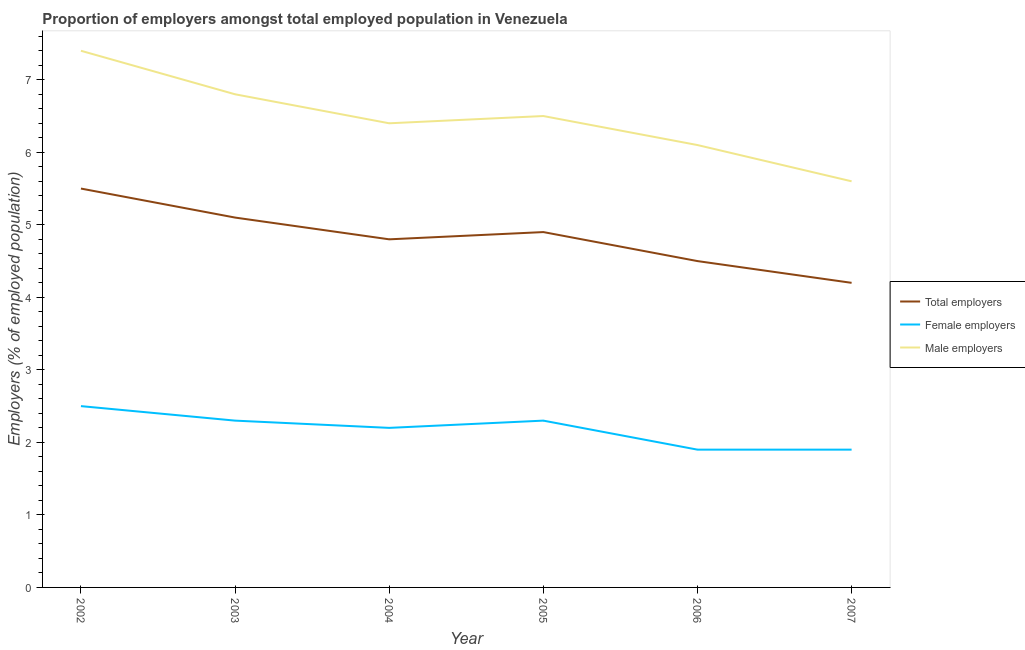Is the number of lines equal to the number of legend labels?
Your response must be concise. Yes. What is the percentage of male employers in 2003?
Your answer should be very brief. 6.8. Across all years, what is the minimum percentage of female employers?
Make the answer very short. 1.9. What is the total percentage of male employers in the graph?
Provide a succinct answer. 38.8. What is the difference between the percentage of male employers in 2002 and that in 2003?
Keep it short and to the point. 0.6. What is the difference between the percentage of male employers in 2005 and the percentage of total employers in 2003?
Offer a very short reply. 1.4. What is the average percentage of female employers per year?
Give a very brief answer. 2.18. In the year 2006, what is the difference between the percentage of female employers and percentage of total employers?
Keep it short and to the point. -2.6. In how many years, is the percentage of female employers greater than 6.4 %?
Your answer should be very brief. 0. What is the ratio of the percentage of male employers in 2003 to that in 2007?
Your answer should be compact. 1.21. Is the difference between the percentage of total employers in 2002 and 2005 greater than the difference between the percentage of male employers in 2002 and 2005?
Give a very brief answer. No. What is the difference between the highest and the second highest percentage of total employers?
Provide a succinct answer. 0.4. What is the difference between the highest and the lowest percentage of female employers?
Provide a succinct answer. 0.6. Is it the case that in every year, the sum of the percentage of total employers and percentage of female employers is greater than the percentage of male employers?
Your answer should be very brief. Yes. Is the percentage of female employers strictly greater than the percentage of male employers over the years?
Provide a short and direct response. No. Is the percentage of male employers strictly less than the percentage of total employers over the years?
Provide a succinct answer. No. How many lines are there?
Ensure brevity in your answer.  3. How many years are there in the graph?
Your response must be concise. 6. Are the values on the major ticks of Y-axis written in scientific E-notation?
Offer a terse response. No. Where does the legend appear in the graph?
Keep it short and to the point. Center right. How many legend labels are there?
Your response must be concise. 3. How are the legend labels stacked?
Ensure brevity in your answer.  Vertical. What is the title of the graph?
Ensure brevity in your answer.  Proportion of employers amongst total employed population in Venezuela. What is the label or title of the X-axis?
Provide a succinct answer. Year. What is the label or title of the Y-axis?
Ensure brevity in your answer.  Employers (% of employed population). What is the Employers (% of employed population) in Male employers in 2002?
Provide a short and direct response. 7.4. What is the Employers (% of employed population) in Total employers in 2003?
Your answer should be compact. 5.1. What is the Employers (% of employed population) in Female employers in 2003?
Your answer should be very brief. 2.3. What is the Employers (% of employed population) of Male employers in 2003?
Your answer should be compact. 6.8. What is the Employers (% of employed population) of Total employers in 2004?
Provide a succinct answer. 4.8. What is the Employers (% of employed population) of Female employers in 2004?
Give a very brief answer. 2.2. What is the Employers (% of employed population) of Male employers in 2004?
Give a very brief answer. 6.4. What is the Employers (% of employed population) in Total employers in 2005?
Offer a terse response. 4.9. What is the Employers (% of employed population) of Female employers in 2005?
Make the answer very short. 2.3. What is the Employers (% of employed population) of Total employers in 2006?
Offer a terse response. 4.5. What is the Employers (% of employed population) of Female employers in 2006?
Provide a succinct answer. 1.9. What is the Employers (% of employed population) of Male employers in 2006?
Offer a very short reply. 6.1. What is the Employers (% of employed population) in Total employers in 2007?
Offer a terse response. 4.2. What is the Employers (% of employed population) of Female employers in 2007?
Provide a short and direct response. 1.9. What is the Employers (% of employed population) of Male employers in 2007?
Give a very brief answer. 5.6. Across all years, what is the maximum Employers (% of employed population) in Female employers?
Your answer should be very brief. 2.5. Across all years, what is the maximum Employers (% of employed population) in Male employers?
Give a very brief answer. 7.4. Across all years, what is the minimum Employers (% of employed population) of Total employers?
Keep it short and to the point. 4.2. Across all years, what is the minimum Employers (% of employed population) of Female employers?
Your answer should be very brief. 1.9. Across all years, what is the minimum Employers (% of employed population) of Male employers?
Make the answer very short. 5.6. What is the total Employers (% of employed population) of Total employers in the graph?
Keep it short and to the point. 29. What is the total Employers (% of employed population) in Female employers in the graph?
Offer a very short reply. 13.1. What is the total Employers (% of employed population) of Male employers in the graph?
Make the answer very short. 38.8. What is the difference between the Employers (% of employed population) in Total employers in 2002 and that in 2003?
Your answer should be compact. 0.4. What is the difference between the Employers (% of employed population) of Female employers in 2002 and that in 2003?
Keep it short and to the point. 0.2. What is the difference between the Employers (% of employed population) of Male employers in 2002 and that in 2004?
Offer a very short reply. 1. What is the difference between the Employers (% of employed population) of Male employers in 2002 and that in 2005?
Offer a terse response. 0.9. What is the difference between the Employers (% of employed population) in Total employers in 2002 and that in 2007?
Give a very brief answer. 1.3. What is the difference between the Employers (% of employed population) in Female employers in 2002 and that in 2007?
Your answer should be compact. 0.6. What is the difference between the Employers (% of employed population) of Total employers in 2003 and that in 2004?
Your answer should be very brief. 0.3. What is the difference between the Employers (% of employed population) of Male employers in 2003 and that in 2005?
Keep it short and to the point. 0.3. What is the difference between the Employers (% of employed population) in Male employers in 2003 and that in 2006?
Your answer should be very brief. 0.7. What is the difference between the Employers (% of employed population) in Female employers in 2004 and that in 2005?
Ensure brevity in your answer.  -0.1. What is the difference between the Employers (% of employed population) of Male employers in 2004 and that in 2005?
Give a very brief answer. -0.1. What is the difference between the Employers (% of employed population) of Total employers in 2004 and that in 2006?
Keep it short and to the point. 0.3. What is the difference between the Employers (% of employed population) in Female employers in 2004 and that in 2006?
Offer a terse response. 0.3. What is the difference between the Employers (% of employed population) of Total employers in 2004 and that in 2007?
Make the answer very short. 0.6. What is the difference between the Employers (% of employed population) in Female employers in 2005 and that in 2006?
Your response must be concise. 0.4. What is the difference between the Employers (% of employed population) of Male employers in 2005 and that in 2007?
Provide a short and direct response. 0.9. What is the difference between the Employers (% of employed population) of Total employers in 2006 and that in 2007?
Make the answer very short. 0.3. What is the difference between the Employers (% of employed population) of Female employers in 2006 and that in 2007?
Give a very brief answer. 0. What is the difference between the Employers (% of employed population) of Total employers in 2002 and the Employers (% of employed population) of Female employers in 2003?
Offer a very short reply. 3.2. What is the difference between the Employers (% of employed population) of Total employers in 2002 and the Employers (% of employed population) of Male employers in 2003?
Make the answer very short. -1.3. What is the difference between the Employers (% of employed population) of Female employers in 2002 and the Employers (% of employed population) of Male employers in 2003?
Offer a terse response. -4.3. What is the difference between the Employers (% of employed population) in Total employers in 2002 and the Employers (% of employed population) in Male employers in 2004?
Provide a succinct answer. -0.9. What is the difference between the Employers (% of employed population) in Female employers in 2002 and the Employers (% of employed population) in Male employers in 2004?
Ensure brevity in your answer.  -3.9. What is the difference between the Employers (% of employed population) of Total employers in 2002 and the Employers (% of employed population) of Female employers in 2005?
Offer a terse response. 3.2. What is the difference between the Employers (% of employed population) of Total employers in 2002 and the Employers (% of employed population) of Male employers in 2005?
Your answer should be compact. -1. What is the difference between the Employers (% of employed population) in Total employers in 2002 and the Employers (% of employed population) in Female employers in 2006?
Keep it short and to the point. 3.6. What is the difference between the Employers (% of employed population) of Total employers in 2002 and the Employers (% of employed population) of Male employers in 2006?
Offer a very short reply. -0.6. What is the difference between the Employers (% of employed population) in Female employers in 2002 and the Employers (% of employed population) in Male employers in 2006?
Provide a short and direct response. -3.6. What is the difference between the Employers (% of employed population) of Female employers in 2002 and the Employers (% of employed population) of Male employers in 2007?
Make the answer very short. -3.1. What is the difference between the Employers (% of employed population) of Female employers in 2003 and the Employers (% of employed population) of Male employers in 2004?
Ensure brevity in your answer.  -4.1. What is the difference between the Employers (% of employed population) of Total employers in 2003 and the Employers (% of employed population) of Female employers in 2005?
Provide a short and direct response. 2.8. What is the difference between the Employers (% of employed population) in Female employers in 2003 and the Employers (% of employed population) in Male employers in 2005?
Provide a succinct answer. -4.2. What is the difference between the Employers (% of employed population) of Total employers in 2003 and the Employers (% of employed population) of Male employers in 2006?
Offer a terse response. -1. What is the difference between the Employers (% of employed population) of Total employers in 2003 and the Employers (% of employed population) of Male employers in 2007?
Your answer should be compact. -0.5. What is the difference between the Employers (% of employed population) of Total employers in 2004 and the Employers (% of employed population) of Male employers in 2005?
Offer a very short reply. -1.7. What is the difference between the Employers (% of employed population) in Total employers in 2004 and the Employers (% of employed population) in Female employers in 2007?
Your response must be concise. 2.9. What is the difference between the Employers (% of employed population) in Total employers in 2004 and the Employers (% of employed population) in Male employers in 2007?
Keep it short and to the point. -0.8. What is the difference between the Employers (% of employed population) in Total employers in 2005 and the Employers (% of employed population) in Female employers in 2006?
Keep it short and to the point. 3. What is the difference between the Employers (% of employed population) of Female employers in 2005 and the Employers (% of employed population) of Male employers in 2006?
Offer a terse response. -3.8. What is the difference between the Employers (% of employed population) of Total employers in 2005 and the Employers (% of employed population) of Female employers in 2007?
Give a very brief answer. 3. What is the difference between the Employers (% of employed population) in Total employers in 2005 and the Employers (% of employed population) in Male employers in 2007?
Make the answer very short. -0.7. What is the difference between the Employers (% of employed population) of Female employers in 2005 and the Employers (% of employed population) of Male employers in 2007?
Provide a succinct answer. -3.3. What is the difference between the Employers (% of employed population) in Female employers in 2006 and the Employers (% of employed population) in Male employers in 2007?
Offer a very short reply. -3.7. What is the average Employers (% of employed population) in Total employers per year?
Your answer should be very brief. 4.83. What is the average Employers (% of employed population) of Female employers per year?
Provide a short and direct response. 2.18. What is the average Employers (% of employed population) of Male employers per year?
Your response must be concise. 6.47. In the year 2002, what is the difference between the Employers (% of employed population) of Total employers and Employers (% of employed population) of Female employers?
Make the answer very short. 3. In the year 2002, what is the difference between the Employers (% of employed population) in Total employers and Employers (% of employed population) in Male employers?
Offer a very short reply. -1.9. In the year 2003, what is the difference between the Employers (% of employed population) in Total employers and Employers (% of employed population) in Male employers?
Your answer should be compact. -1.7. In the year 2004, what is the difference between the Employers (% of employed population) of Total employers and Employers (% of employed population) of Male employers?
Make the answer very short. -1.6. In the year 2005, what is the difference between the Employers (% of employed population) in Total employers and Employers (% of employed population) in Male employers?
Keep it short and to the point. -1.6. In the year 2005, what is the difference between the Employers (% of employed population) in Female employers and Employers (% of employed population) in Male employers?
Your answer should be compact. -4.2. In the year 2006, what is the difference between the Employers (% of employed population) in Total employers and Employers (% of employed population) in Female employers?
Provide a short and direct response. 2.6. In the year 2006, what is the difference between the Employers (% of employed population) in Total employers and Employers (% of employed population) in Male employers?
Make the answer very short. -1.6. In the year 2007, what is the difference between the Employers (% of employed population) of Total employers and Employers (% of employed population) of Male employers?
Offer a very short reply. -1.4. What is the ratio of the Employers (% of employed population) of Total employers in 2002 to that in 2003?
Your answer should be compact. 1.08. What is the ratio of the Employers (% of employed population) of Female employers in 2002 to that in 2003?
Give a very brief answer. 1.09. What is the ratio of the Employers (% of employed population) in Male employers in 2002 to that in 2003?
Make the answer very short. 1.09. What is the ratio of the Employers (% of employed population) of Total employers in 2002 to that in 2004?
Keep it short and to the point. 1.15. What is the ratio of the Employers (% of employed population) of Female employers in 2002 to that in 2004?
Provide a short and direct response. 1.14. What is the ratio of the Employers (% of employed population) of Male employers in 2002 to that in 2004?
Provide a short and direct response. 1.16. What is the ratio of the Employers (% of employed population) of Total employers in 2002 to that in 2005?
Provide a succinct answer. 1.12. What is the ratio of the Employers (% of employed population) in Female employers in 2002 to that in 2005?
Make the answer very short. 1.09. What is the ratio of the Employers (% of employed population) in Male employers in 2002 to that in 2005?
Make the answer very short. 1.14. What is the ratio of the Employers (% of employed population) in Total employers in 2002 to that in 2006?
Your response must be concise. 1.22. What is the ratio of the Employers (% of employed population) of Female employers in 2002 to that in 2006?
Offer a terse response. 1.32. What is the ratio of the Employers (% of employed population) in Male employers in 2002 to that in 2006?
Provide a succinct answer. 1.21. What is the ratio of the Employers (% of employed population) of Total employers in 2002 to that in 2007?
Keep it short and to the point. 1.31. What is the ratio of the Employers (% of employed population) of Female employers in 2002 to that in 2007?
Your response must be concise. 1.32. What is the ratio of the Employers (% of employed population) in Male employers in 2002 to that in 2007?
Provide a succinct answer. 1.32. What is the ratio of the Employers (% of employed population) in Female employers in 2003 to that in 2004?
Make the answer very short. 1.05. What is the ratio of the Employers (% of employed population) of Total employers in 2003 to that in 2005?
Ensure brevity in your answer.  1.04. What is the ratio of the Employers (% of employed population) in Male employers in 2003 to that in 2005?
Offer a terse response. 1.05. What is the ratio of the Employers (% of employed population) of Total employers in 2003 to that in 2006?
Give a very brief answer. 1.13. What is the ratio of the Employers (% of employed population) in Female employers in 2003 to that in 2006?
Your response must be concise. 1.21. What is the ratio of the Employers (% of employed population) of Male employers in 2003 to that in 2006?
Offer a very short reply. 1.11. What is the ratio of the Employers (% of employed population) of Total employers in 2003 to that in 2007?
Ensure brevity in your answer.  1.21. What is the ratio of the Employers (% of employed population) in Female employers in 2003 to that in 2007?
Provide a succinct answer. 1.21. What is the ratio of the Employers (% of employed population) in Male employers in 2003 to that in 2007?
Give a very brief answer. 1.21. What is the ratio of the Employers (% of employed population) in Total employers in 2004 to that in 2005?
Your response must be concise. 0.98. What is the ratio of the Employers (% of employed population) of Female employers in 2004 to that in 2005?
Your answer should be compact. 0.96. What is the ratio of the Employers (% of employed population) in Male employers in 2004 to that in 2005?
Offer a terse response. 0.98. What is the ratio of the Employers (% of employed population) of Total employers in 2004 to that in 2006?
Your response must be concise. 1.07. What is the ratio of the Employers (% of employed population) in Female employers in 2004 to that in 2006?
Keep it short and to the point. 1.16. What is the ratio of the Employers (% of employed population) of Male employers in 2004 to that in 2006?
Offer a very short reply. 1.05. What is the ratio of the Employers (% of employed population) of Female employers in 2004 to that in 2007?
Ensure brevity in your answer.  1.16. What is the ratio of the Employers (% of employed population) of Total employers in 2005 to that in 2006?
Give a very brief answer. 1.09. What is the ratio of the Employers (% of employed population) of Female employers in 2005 to that in 2006?
Your answer should be very brief. 1.21. What is the ratio of the Employers (% of employed population) of Male employers in 2005 to that in 2006?
Offer a terse response. 1.07. What is the ratio of the Employers (% of employed population) in Female employers in 2005 to that in 2007?
Your response must be concise. 1.21. What is the ratio of the Employers (% of employed population) of Male employers in 2005 to that in 2007?
Your answer should be compact. 1.16. What is the ratio of the Employers (% of employed population) of Total employers in 2006 to that in 2007?
Make the answer very short. 1.07. What is the ratio of the Employers (% of employed population) in Male employers in 2006 to that in 2007?
Provide a succinct answer. 1.09. What is the difference between the highest and the second highest Employers (% of employed population) of Total employers?
Make the answer very short. 0.4. What is the difference between the highest and the second highest Employers (% of employed population) of Female employers?
Offer a very short reply. 0.2. What is the difference between the highest and the second highest Employers (% of employed population) in Male employers?
Keep it short and to the point. 0.6. What is the difference between the highest and the lowest Employers (% of employed population) of Total employers?
Your answer should be very brief. 1.3. 